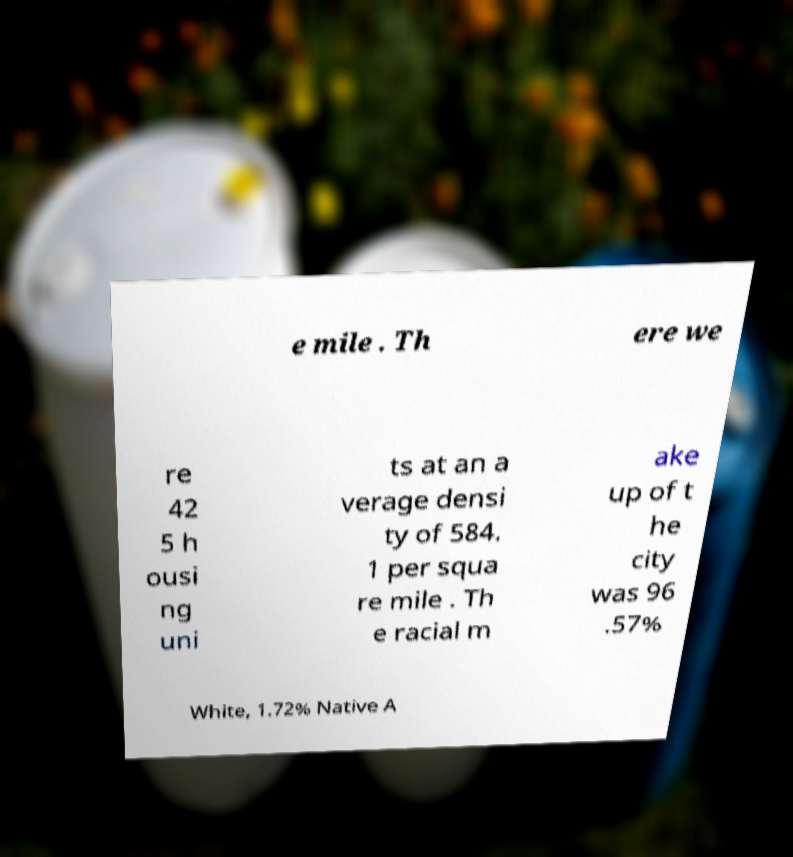For documentation purposes, I need the text within this image transcribed. Could you provide that? e mile . Th ere we re 42 5 h ousi ng uni ts at an a verage densi ty of 584. 1 per squa re mile . Th e racial m ake up of t he city was 96 .57% White, 1.72% Native A 